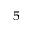<formula> <loc_0><loc_0><loc_500><loc_500>^ { 5 }</formula> 